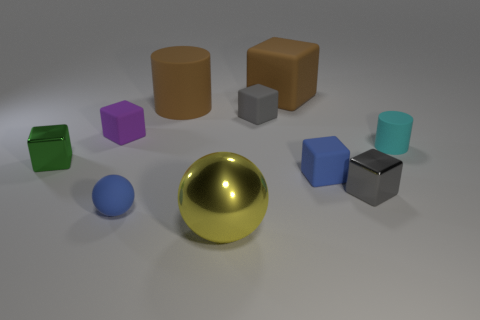Can you tell me which objects are spheres and their colors? In the image, there is only one sphere, and it is golden in color. 